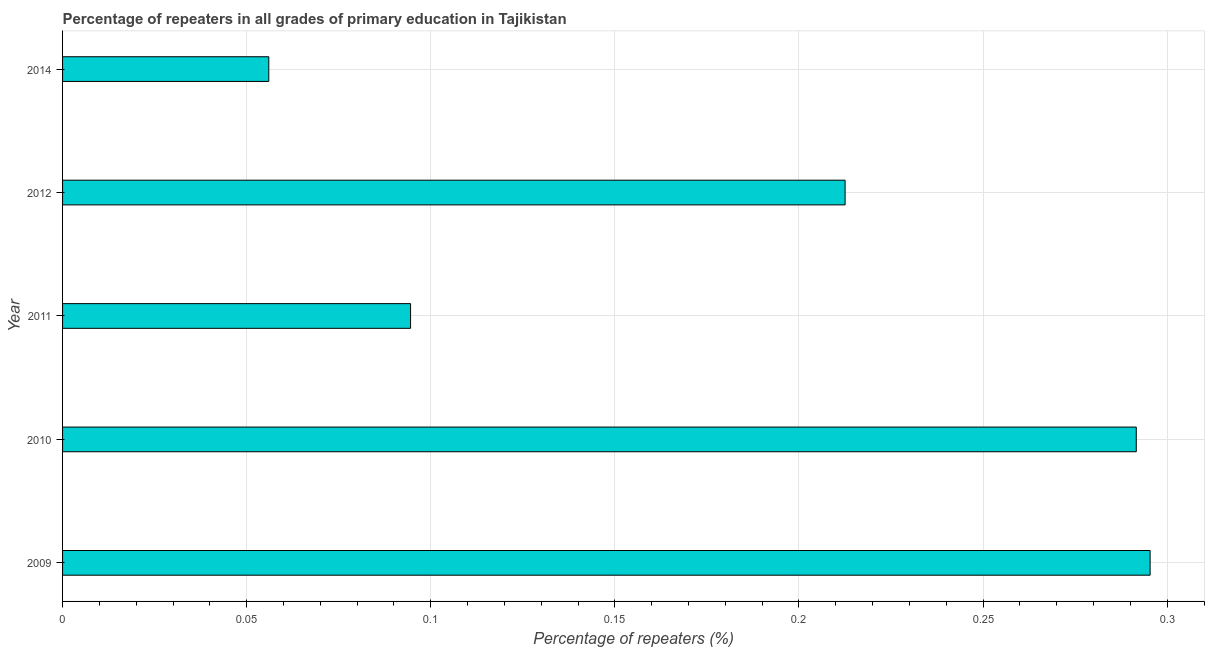Does the graph contain any zero values?
Ensure brevity in your answer.  No. What is the title of the graph?
Offer a terse response. Percentage of repeaters in all grades of primary education in Tajikistan. What is the label or title of the X-axis?
Your response must be concise. Percentage of repeaters (%). What is the percentage of repeaters in primary education in 2014?
Your answer should be very brief. 0.06. Across all years, what is the maximum percentage of repeaters in primary education?
Ensure brevity in your answer.  0.3. Across all years, what is the minimum percentage of repeaters in primary education?
Ensure brevity in your answer.  0.06. What is the sum of the percentage of repeaters in primary education?
Offer a terse response. 0.95. What is the difference between the percentage of repeaters in primary education in 2011 and 2012?
Ensure brevity in your answer.  -0.12. What is the average percentage of repeaters in primary education per year?
Your answer should be compact. 0.19. What is the median percentage of repeaters in primary education?
Make the answer very short. 0.21. In how many years, is the percentage of repeaters in primary education greater than 0.19 %?
Offer a very short reply. 3. Do a majority of the years between 2014 and 2010 (inclusive) have percentage of repeaters in primary education greater than 0.11 %?
Make the answer very short. Yes. What is the ratio of the percentage of repeaters in primary education in 2011 to that in 2014?
Provide a short and direct response. 1.69. Is the percentage of repeaters in primary education in 2010 less than that in 2012?
Make the answer very short. No. What is the difference between the highest and the second highest percentage of repeaters in primary education?
Make the answer very short. 0. What is the difference between the highest and the lowest percentage of repeaters in primary education?
Offer a terse response. 0.24. In how many years, is the percentage of repeaters in primary education greater than the average percentage of repeaters in primary education taken over all years?
Your answer should be very brief. 3. How many bars are there?
Your answer should be compact. 5. Are all the bars in the graph horizontal?
Ensure brevity in your answer.  Yes. How many years are there in the graph?
Make the answer very short. 5. What is the difference between two consecutive major ticks on the X-axis?
Your response must be concise. 0.05. Are the values on the major ticks of X-axis written in scientific E-notation?
Offer a very short reply. No. What is the Percentage of repeaters (%) of 2009?
Your answer should be compact. 0.3. What is the Percentage of repeaters (%) of 2010?
Your answer should be very brief. 0.29. What is the Percentage of repeaters (%) in 2011?
Provide a short and direct response. 0.09. What is the Percentage of repeaters (%) of 2012?
Give a very brief answer. 0.21. What is the Percentage of repeaters (%) of 2014?
Provide a short and direct response. 0.06. What is the difference between the Percentage of repeaters (%) in 2009 and 2010?
Your answer should be compact. 0. What is the difference between the Percentage of repeaters (%) in 2009 and 2011?
Give a very brief answer. 0.2. What is the difference between the Percentage of repeaters (%) in 2009 and 2012?
Offer a very short reply. 0.08. What is the difference between the Percentage of repeaters (%) in 2009 and 2014?
Give a very brief answer. 0.24. What is the difference between the Percentage of repeaters (%) in 2010 and 2011?
Offer a terse response. 0.2. What is the difference between the Percentage of repeaters (%) in 2010 and 2012?
Your answer should be very brief. 0.08. What is the difference between the Percentage of repeaters (%) in 2010 and 2014?
Keep it short and to the point. 0.24. What is the difference between the Percentage of repeaters (%) in 2011 and 2012?
Offer a terse response. -0.12. What is the difference between the Percentage of repeaters (%) in 2011 and 2014?
Offer a very short reply. 0.04. What is the difference between the Percentage of repeaters (%) in 2012 and 2014?
Offer a very short reply. 0.16. What is the ratio of the Percentage of repeaters (%) in 2009 to that in 2010?
Ensure brevity in your answer.  1.01. What is the ratio of the Percentage of repeaters (%) in 2009 to that in 2011?
Your answer should be very brief. 3.12. What is the ratio of the Percentage of repeaters (%) in 2009 to that in 2012?
Your answer should be compact. 1.39. What is the ratio of the Percentage of repeaters (%) in 2009 to that in 2014?
Your answer should be compact. 5.27. What is the ratio of the Percentage of repeaters (%) in 2010 to that in 2011?
Offer a very short reply. 3.08. What is the ratio of the Percentage of repeaters (%) in 2010 to that in 2012?
Your answer should be very brief. 1.37. What is the ratio of the Percentage of repeaters (%) in 2010 to that in 2014?
Your answer should be compact. 5.21. What is the ratio of the Percentage of repeaters (%) in 2011 to that in 2012?
Offer a very short reply. 0.45. What is the ratio of the Percentage of repeaters (%) in 2011 to that in 2014?
Give a very brief answer. 1.69. What is the ratio of the Percentage of repeaters (%) in 2012 to that in 2014?
Ensure brevity in your answer.  3.79. 